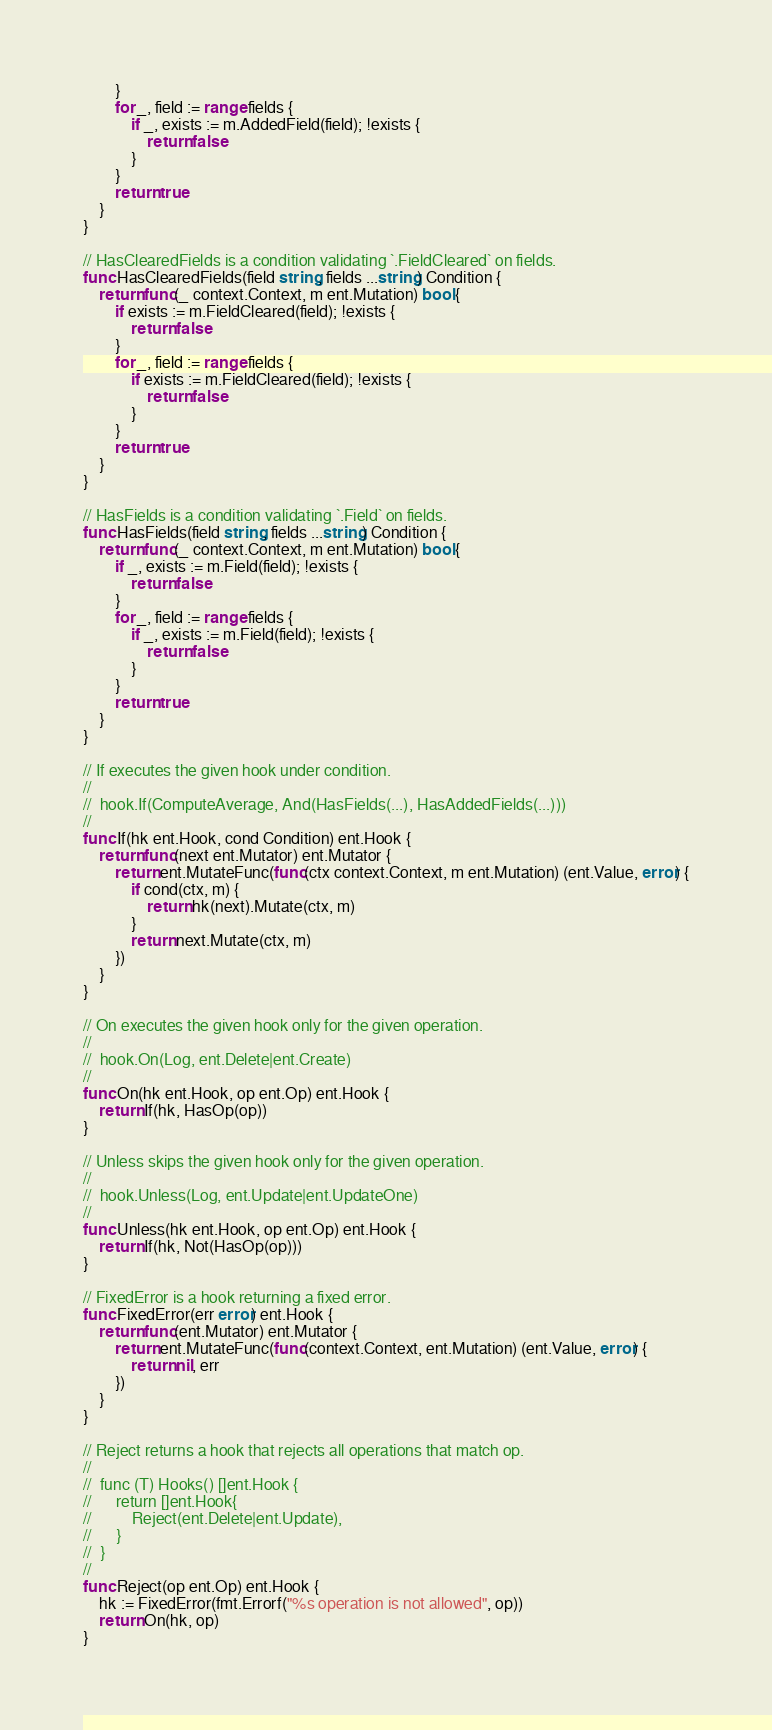<code> <loc_0><loc_0><loc_500><loc_500><_Go_>		}
		for _, field := range fields {
			if _, exists := m.AddedField(field); !exists {
				return false
			}
		}
		return true
	}
}

// HasClearedFields is a condition validating `.FieldCleared` on fields.
func HasClearedFields(field string, fields ...string) Condition {
	return func(_ context.Context, m ent.Mutation) bool {
		if exists := m.FieldCleared(field); !exists {
			return false
		}
		for _, field := range fields {
			if exists := m.FieldCleared(field); !exists {
				return false
			}
		}
		return true
	}
}

// HasFields is a condition validating `.Field` on fields.
func HasFields(field string, fields ...string) Condition {
	return func(_ context.Context, m ent.Mutation) bool {
		if _, exists := m.Field(field); !exists {
			return false
		}
		for _, field := range fields {
			if _, exists := m.Field(field); !exists {
				return false
			}
		}
		return true
	}
}

// If executes the given hook under condition.
//
//	hook.If(ComputeAverage, And(HasFields(...), HasAddedFields(...)))
//
func If(hk ent.Hook, cond Condition) ent.Hook {
	return func(next ent.Mutator) ent.Mutator {
		return ent.MutateFunc(func(ctx context.Context, m ent.Mutation) (ent.Value, error) {
			if cond(ctx, m) {
				return hk(next).Mutate(ctx, m)
			}
			return next.Mutate(ctx, m)
		})
	}
}

// On executes the given hook only for the given operation.
//
//	hook.On(Log, ent.Delete|ent.Create)
//
func On(hk ent.Hook, op ent.Op) ent.Hook {
	return If(hk, HasOp(op))
}

// Unless skips the given hook only for the given operation.
//
//	hook.Unless(Log, ent.Update|ent.UpdateOne)
//
func Unless(hk ent.Hook, op ent.Op) ent.Hook {
	return If(hk, Not(HasOp(op)))
}

// FixedError is a hook returning a fixed error.
func FixedError(err error) ent.Hook {
	return func(ent.Mutator) ent.Mutator {
		return ent.MutateFunc(func(context.Context, ent.Mutation) (ent.Value, error) {
			return nil, err
		})
	}
}

// Reject returns a hook that rejects all operations that match op.
//
//	func (T) Hooks() []ent.Hook {
//		return []ent.Hook{
//			Reject(ent.Delete|ent.Update),
//		}
//	}
//
func Reject(op ent.Op) ent.Hook {
	hk := FixedError(fmt.Errorf("%s operation is not allowed", op))
	return On(hk, op)
}
</code> 